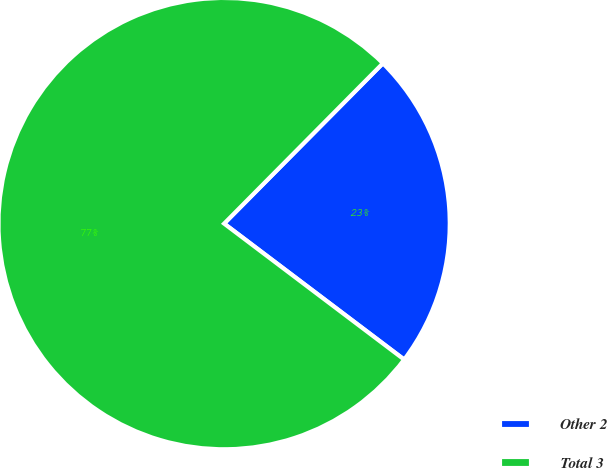Convert chart to OTSL. <chart><loc_0><loc_0><loc_500><loc_500><pie_chart><fcel>Other 2<fcel>Total 3<nl><fcel>22.87%<fcel>77.13%<nl></chart> 